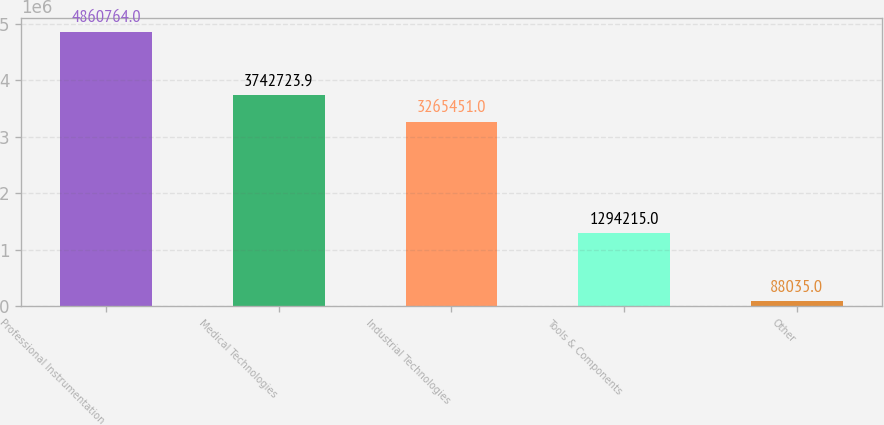Convert chart. <chart><loc_0><loc_0><loc_500><loc_500><bar_chart><fcel>Professional Instrumentation<fcel>Medical Technologies<fcel>Industrial Technologies<fcel>Tools & Components<fcel>Other<nl><fcel>4.86076e+06<fcel>3.74272e+06<fcel>3.26545e+06<fcel>1.29422e+06<fcel>88035<nl></chart> 